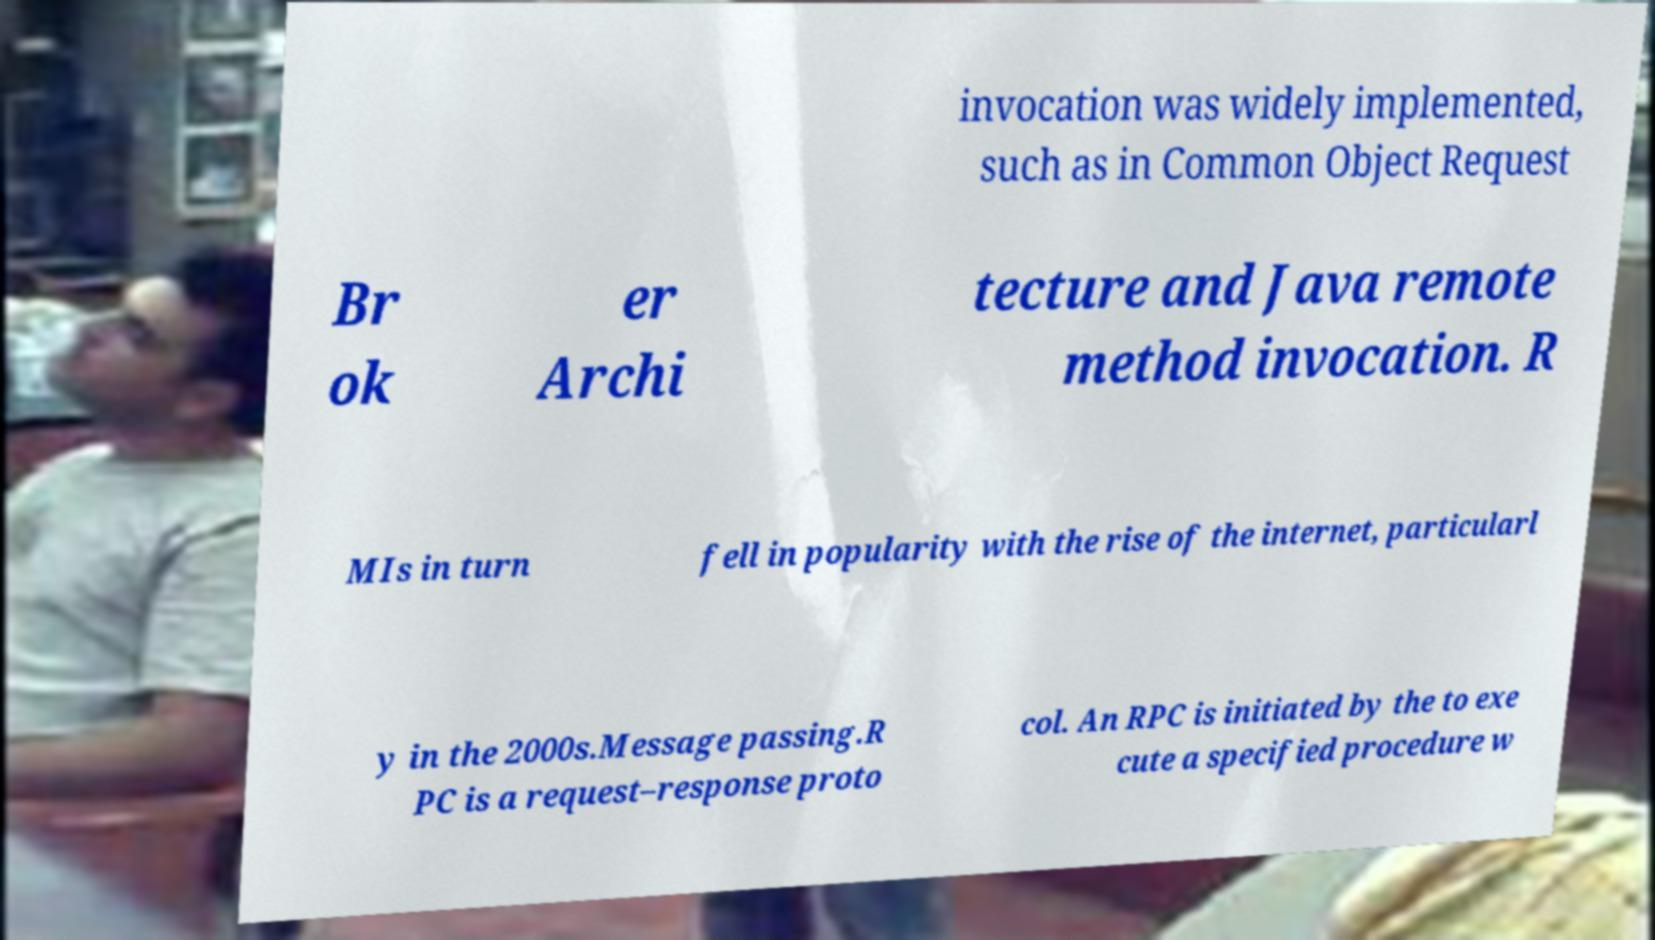Please identify and transcribe the text found in this image. invocation was widely implemented, such as in Common Object Request Br ok er Archi tecture and Java remote method invocation. R MIs in turn fell in popularity with the rise of the internet, particularl y in the 2000s.Message passing.R PC is a request–response proto col. An RPC is initiated by the to exe cute a specified procedure w 